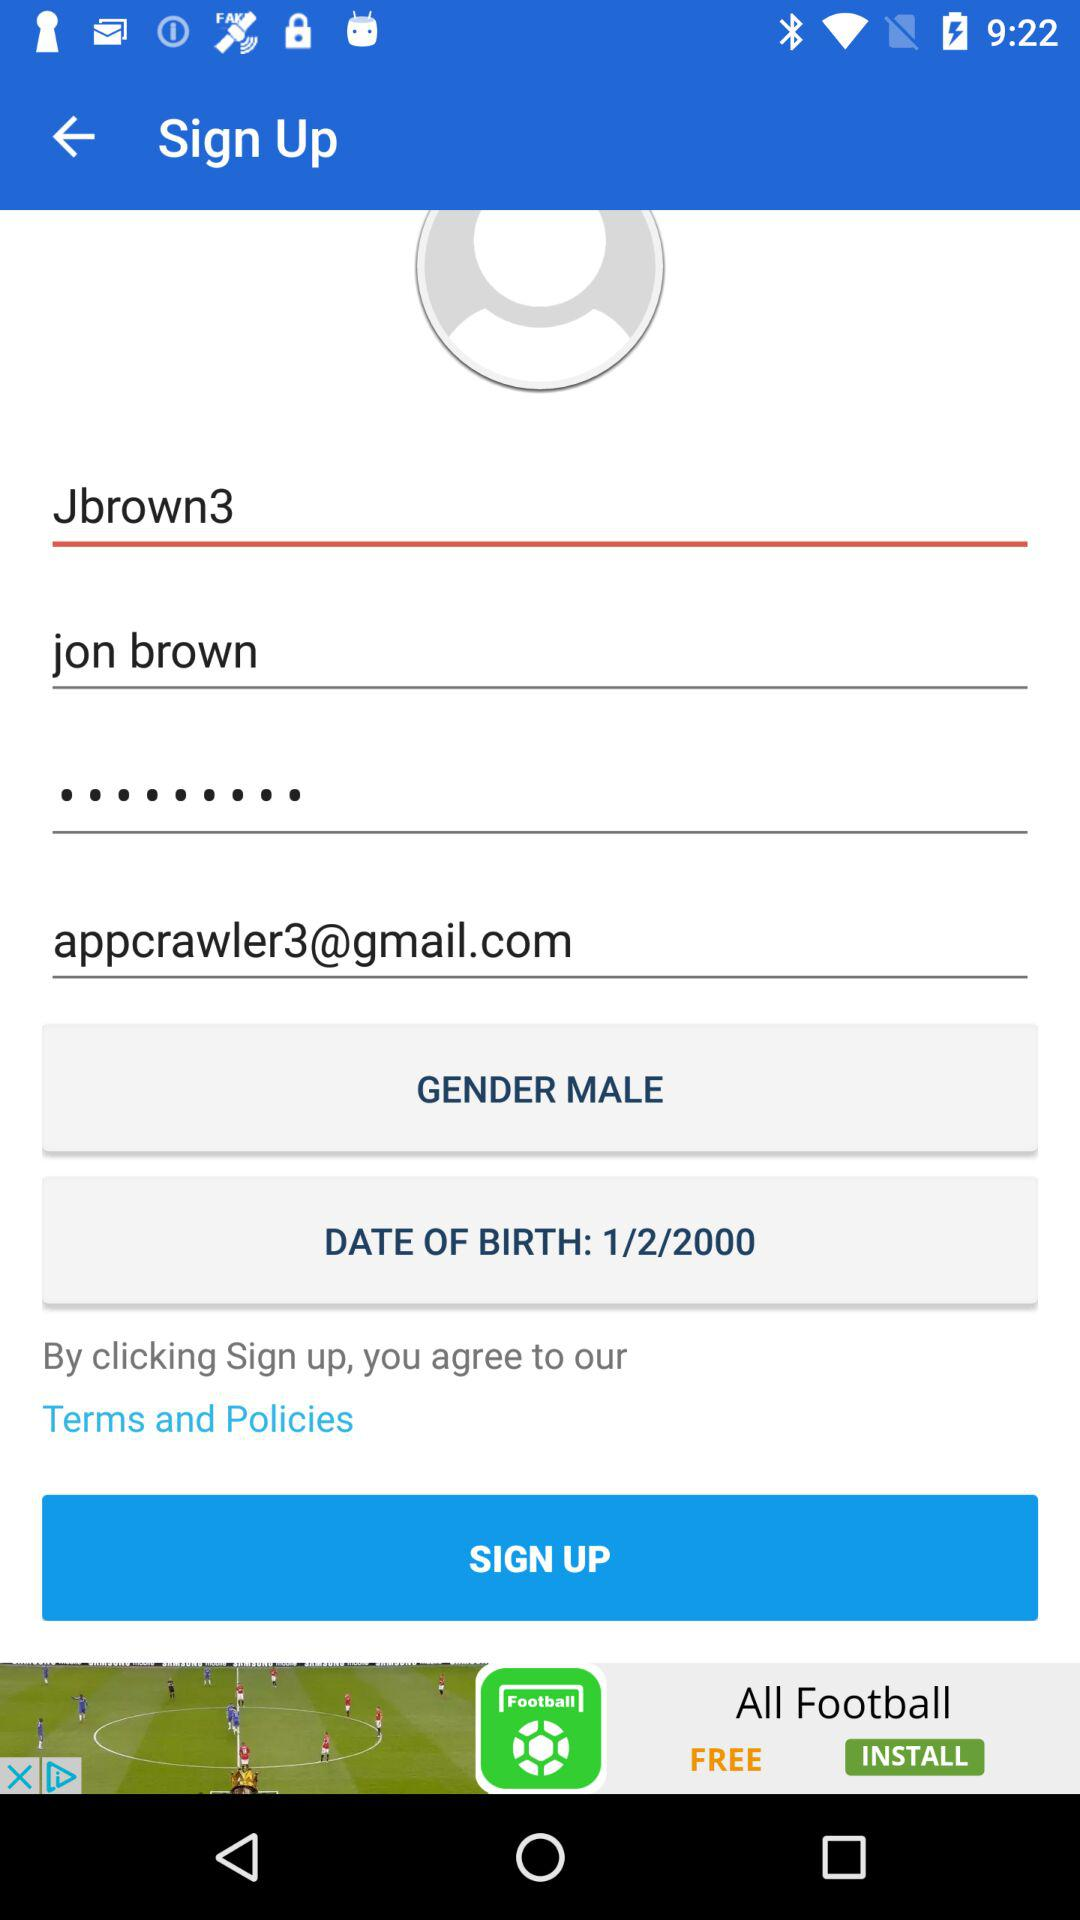What is the given date of birth? The given date of birth is 1/2/2000. 